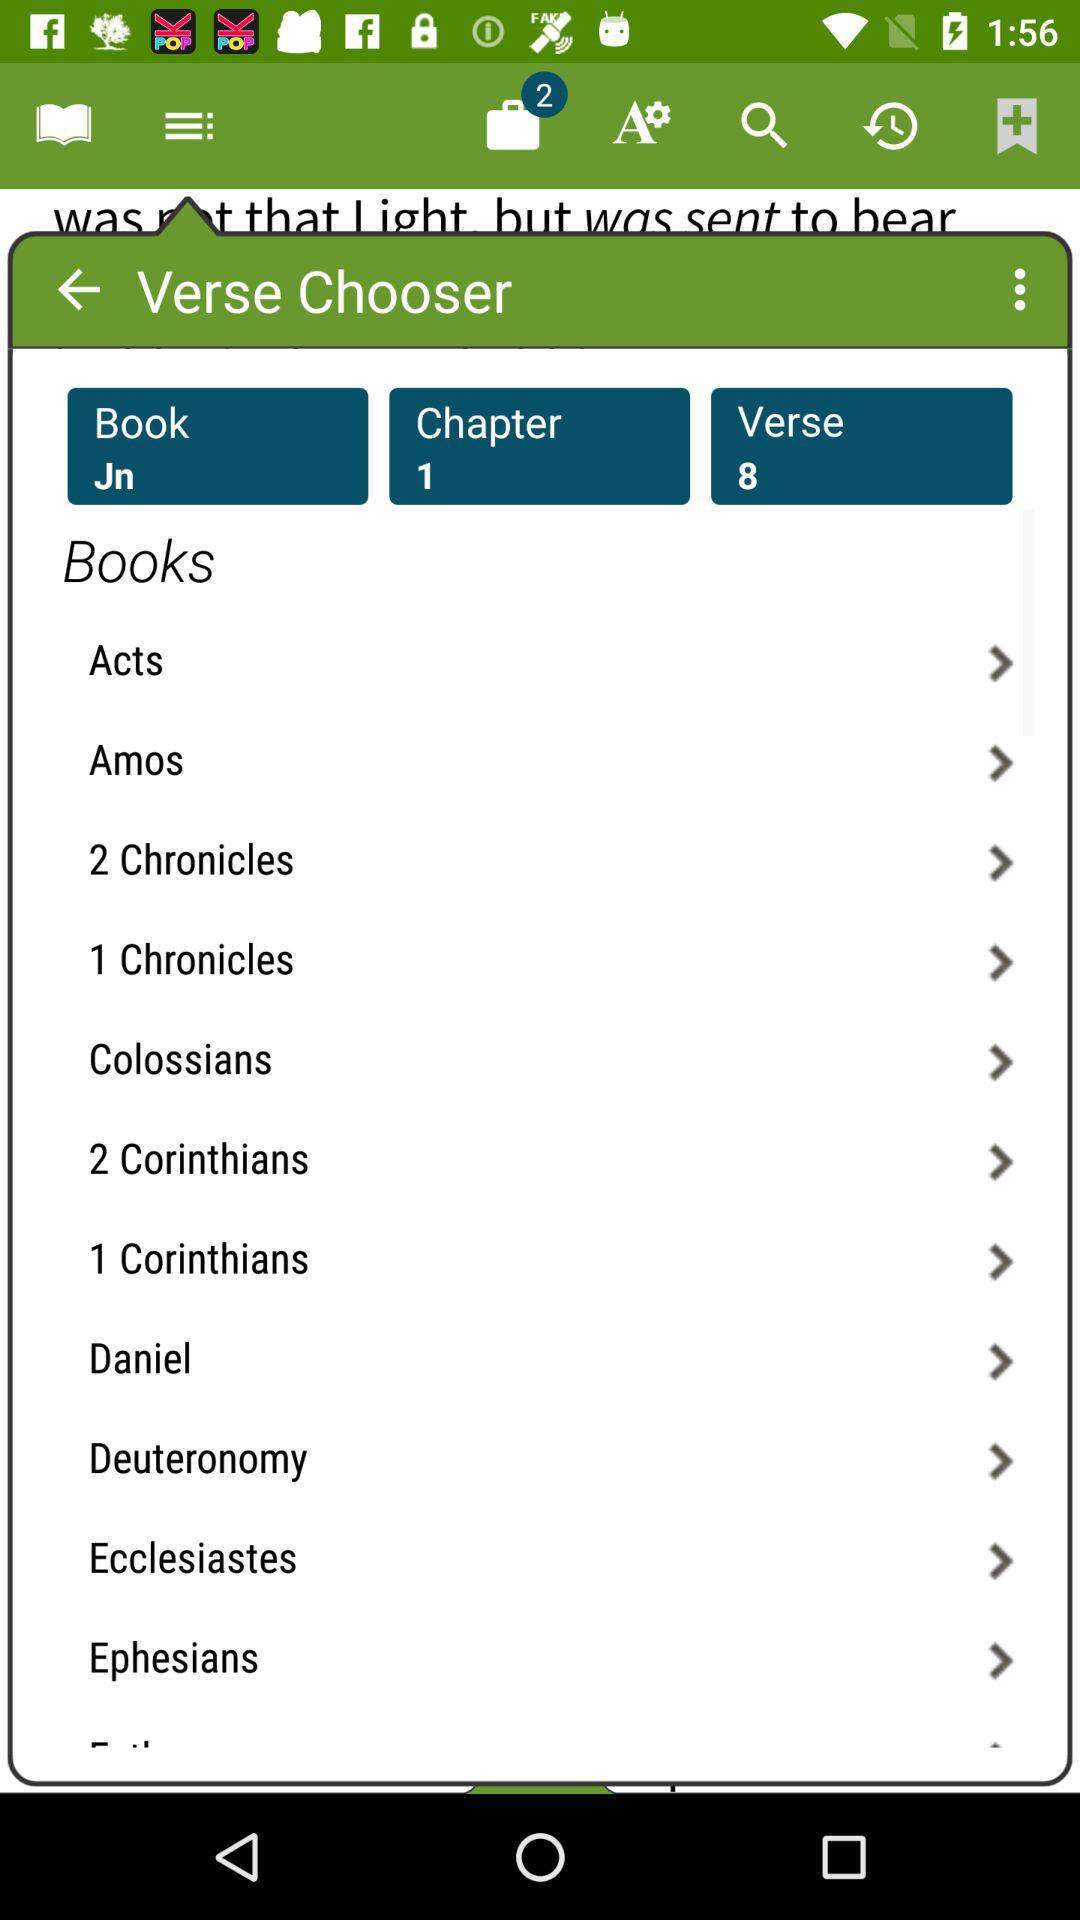How many unread notifications are there? There are 2 unread notifications. 